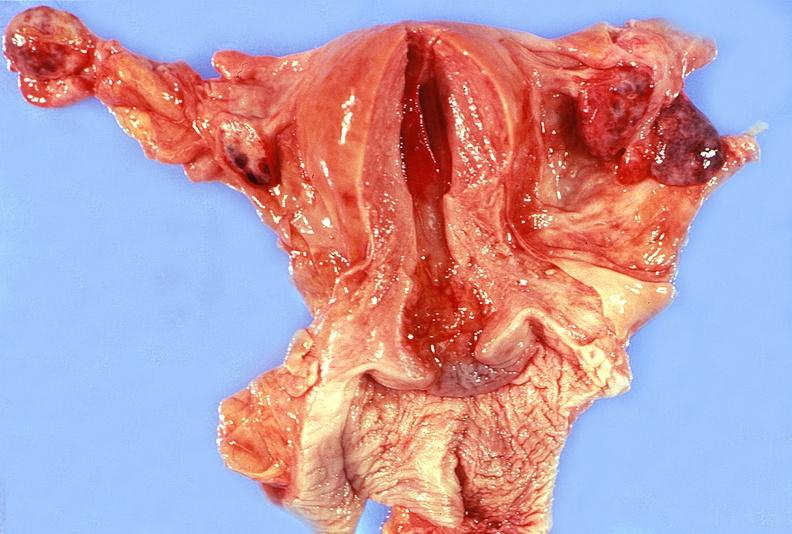what does this image show?
Answer the question using a single word or phrase. Uterus 